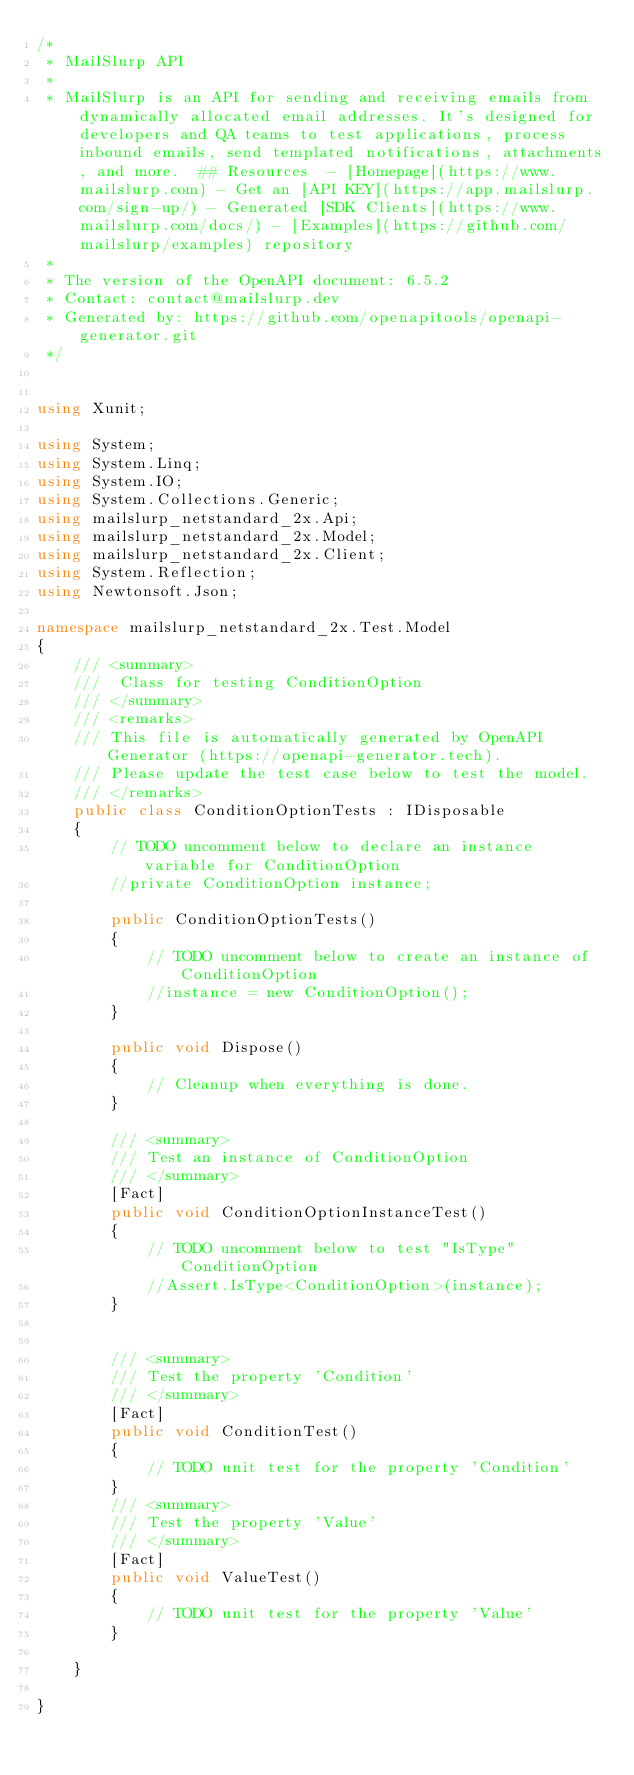<code> <loc_0><loc_0><loc_500><loc_500><_C#_>/*
 * MailSlurp API
 *
 * MailSlurp is an API for sending and receiving emails from dynamically allocated email addresses. It's designed for developers and QA teams to test applications, process inbound emails, send templated notifications, attachments, and more.  ## Resources  - [Homepage](https://www.mailslurp.com) - Get an [API KEY](https://app.mailslurp.com/sign-up/) - Generated [SDK Clients](https://www.mailslurp.com/docs/) - [Examples](https://github.com/mailslurp/examples) repository
 *
 * The version of the OpenAPI document: 6.5.2
 * Contact: contact@mailslurp.dev
 * Generated by: https://github.com/openapitools/openapi-generator.git
 */


using Xunit;

using System;
using System.Linq;
using System.IO;
using System.Collections.Generic;
using mailslurp_netstandard_2x.Api;
using mailslurp_netstandard_2x.Model;
using mailslurp_netstandard_2x.Client;
using System.Reflection;
using Newtonsoft.Json;

namespace mailslurp_netstandard_2x.Test.Model
{
    /// <summary>
    ///  Class for testing ConditionOption
    /// </summary>
    /// <remarks>
    /// This file is automatically generated by OpenAPI Generator (https://openapi-generator.tech).
    /// Please update the test case below to test the model.
    /// </remarks>
    public class ConditionOptionTests : IDisposable
    {
        // TODO uncomment below to declare an instance variable for ConditionOption
        //private ConditionOption instance;

        public ConditionOptionTests()
        {
            // TODO uncomment below to create an instance of ConditionOption
            //instance = new ConditionOption();
        }

        public void Dispose()
        {
            // Cleanup when everything is done.
        }

        /// <summary>
        /// Test an instance of ConditionOption
        /// </summary>
        [Fact]
        public void ConditionOptionInstanceTest()
        {
            // TODO uncomment below to test "IsType" ConditionOption
            //Assert.IsType<ConditionOption>(instance);
        }


        /// <summary>
        /// Test the property 'Condition'
        /// </summary>
        [Fact]
        public void ConditionTest()
        {
            // TODO unit test for the property 'Condition'
        }
        /// <summary>
        /// Test the property 'Value'
        /// </summary>
        [Fact]
        public void ValueTest()
        {
            // TODO unit test for the property 'Value'
        }

    }

}
</code> 